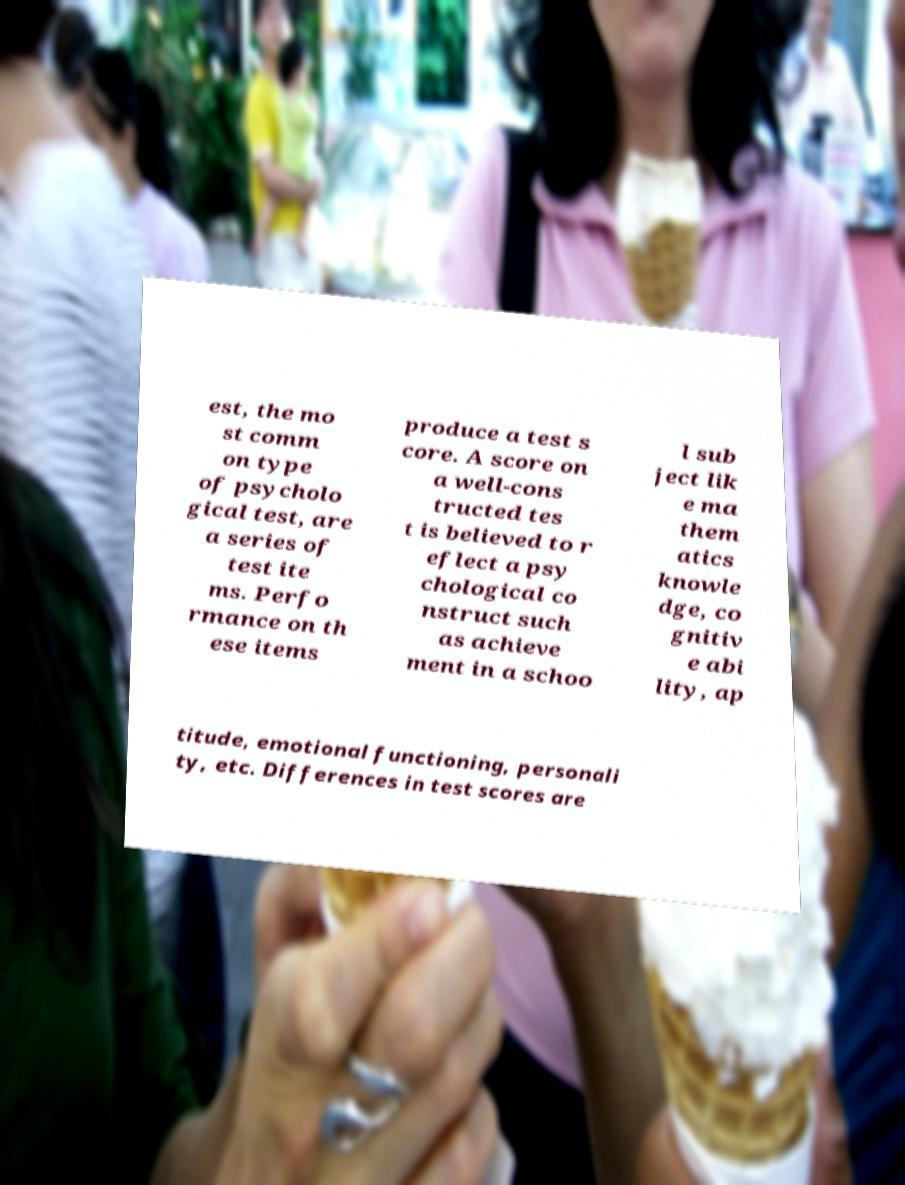I need the written content from this picture converted into text. Can you do that? est, the mo st comm on type of psycholo gical test, are a series of test ite ms. Perfo rmance on th ese items produce a test s core. A score on a well-cons tructed tes t is believed to r eflect a psy chological co nstruct such as achieve ment in a schoo l sub ject lik e ma them atics knowle dge, co gnitiv e abi lity, ap titude, emotional functioning, personali ty, etc. Differences in test scores are 